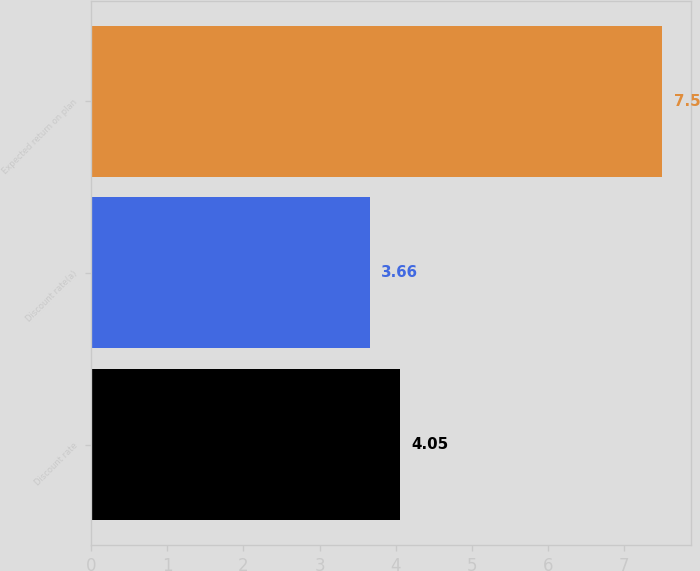Convert chart to OTSL. <chart><loc_0><loc_0><loc_500><loc_500><bar_chart><fcel>Discount rate<fcel>Discount rate(a)<fcel>Expected return on plan<nl><fcel>4.05<fcel>3.66<fcel>7.5<nl></chart> 